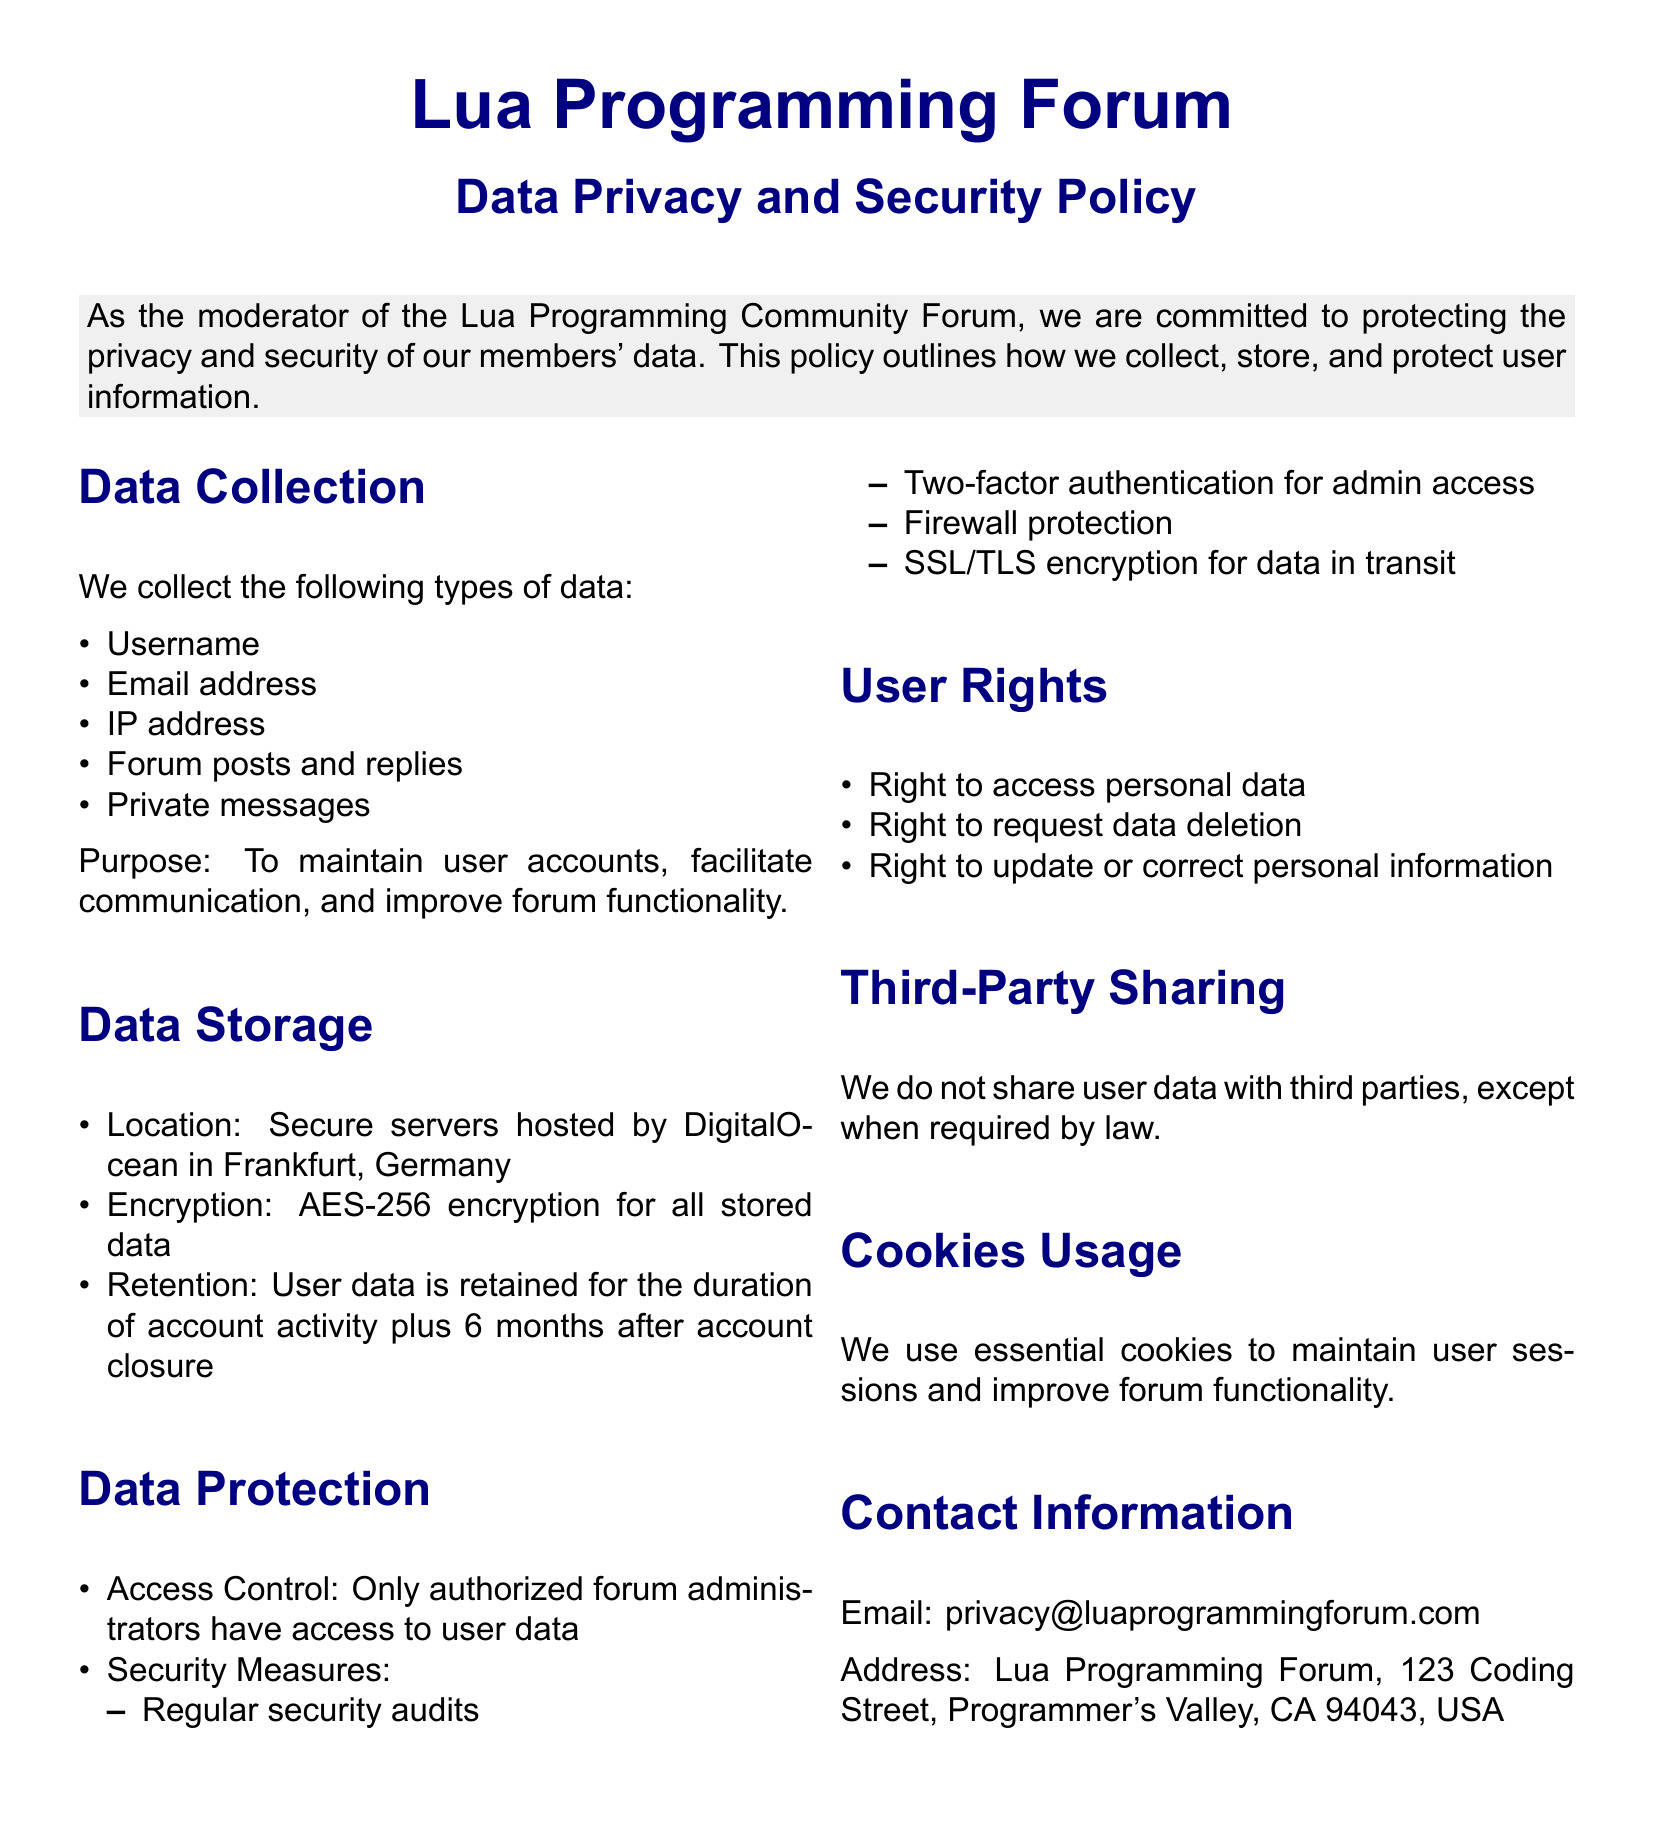What types of data are collected? The document lists specific types of data under the Data Collection section, including Username and Email address.
Answer: Username, Email address, IP address, Forum posts and replies, Private messages Where is user data stored? The Data Storage section specifies the location where user data is hosted.
Answer: Secure servers hosted by DigitalOcean in Frankfurt, Germany What encryption method is used for stored data? The Data Storage section mentions the specific encryption technique utilized for user data.
Answer: AES-256 encryption Who has access to user data? According to the Data Protection section, it indicates who is authorized to access user data within the forum.
Answer: Authorized forum administrators What rights do users have regarding their personal data? The User Rights section outlines the entitlements users have concerning their personal information.
Answer: Right to access personal data, Right to request data deletion, Right to update or correct personal information What kind of security measures are in place? The document lists various measures taken to protect user data in the Data Protection section.
Answer: Regular security audits, Two-factor authentication for admin access, Firewall protection, SSL/TLS encryption Is user data shared with third parties? The section on Third-Party Sharing states the policy regarding user data sharing practices.
Answer: No What is the purpose of data collection? The Data Collection section explains why the forum collects user data.
Answer: To maintain user accounts, facilitate communication, and improve forum functionality What is the retention period for user data after account closure? The Data Storage section provides information on how long user data is retained after account closure.
Answer: 6 months after account closure 